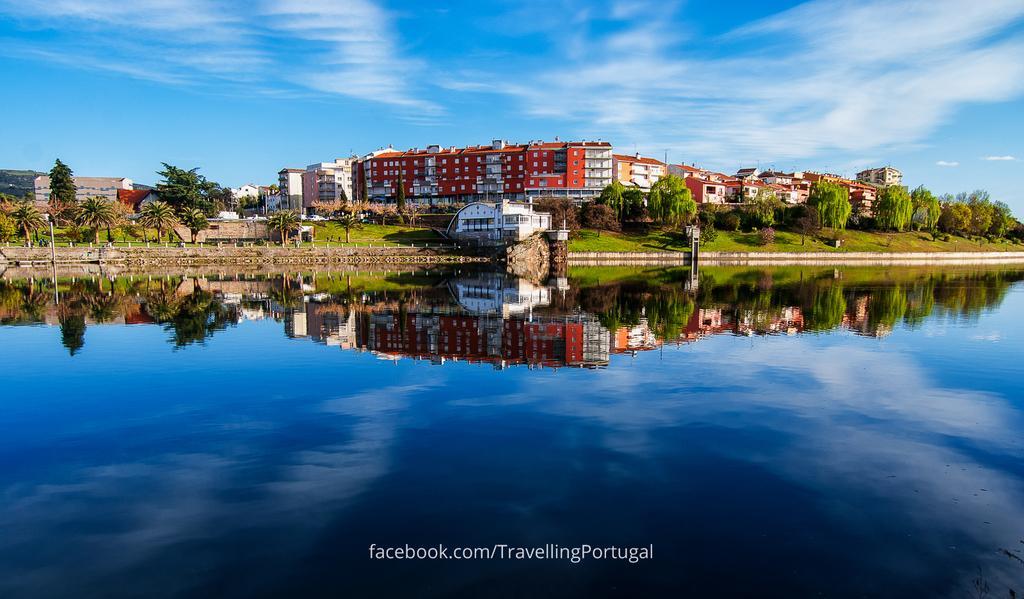How would you summarize this image in a sentence or two? Sky is cloudy. Here we can see water. Background there are trees, grass and buildings. In this water there is a reflection of grass, trees and buildings. Bottom of the image there is a watermark. 